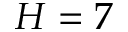Convert formula to latex. <formula><loc_0><loc_0><loc_500><loc_500>H = 7</formula> 